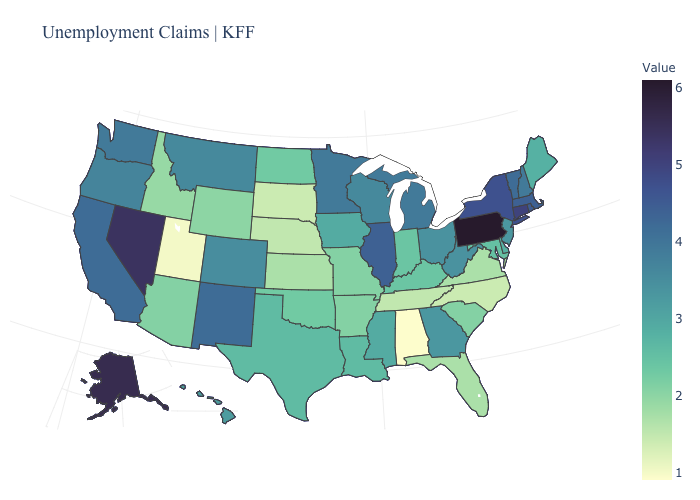Does Pennsylvania have the highest value in the USA?
Short answer required. Yes. Does Pennsylvania have the highest value in the Northeast?
Answer briefly. Yes. Is the legend a continuous bar?
Keep it brief. Yes. Does California have the lowest value in the USA?
Be succinct. No. Which states hav the highest value in the West?
Concise answer only. Alaska. 